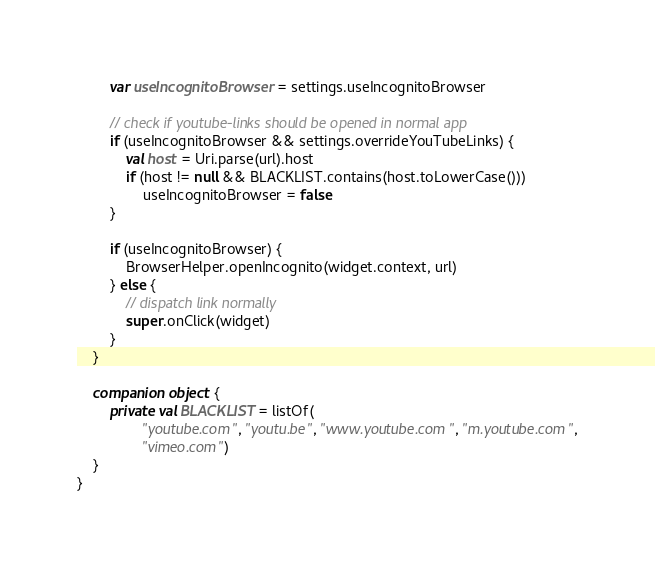<code> <loc_0><loc_0><loc_500><loc_500><_Kotlin_>        var useIncognitoBrowser = settings.useIncognitoBrowser

        // check if youtube-links should be opened in normal app
        if (useIncognitoBrowser && settings.overrideYouTubeLinks) {
            val host = Uri.parse(url).host
            if (host != null && BLACKLIST.contains(host.toLowerCase()))
                useIncognitoBrowser = false
        }

        if (useIncognitoBrowser) {
            BrowserHelper.openIncognito(widget.context, url)
        } else {
            // dispatch link normally
            super.onClick(widget)
        }
    }

    companion object {
        private val BLACKLIST = listOf(
                "youtube.com", "youtu.be", "www.youtube.com", "m.youtube.com",
                "vimeo.com")
    }
}
</code> 